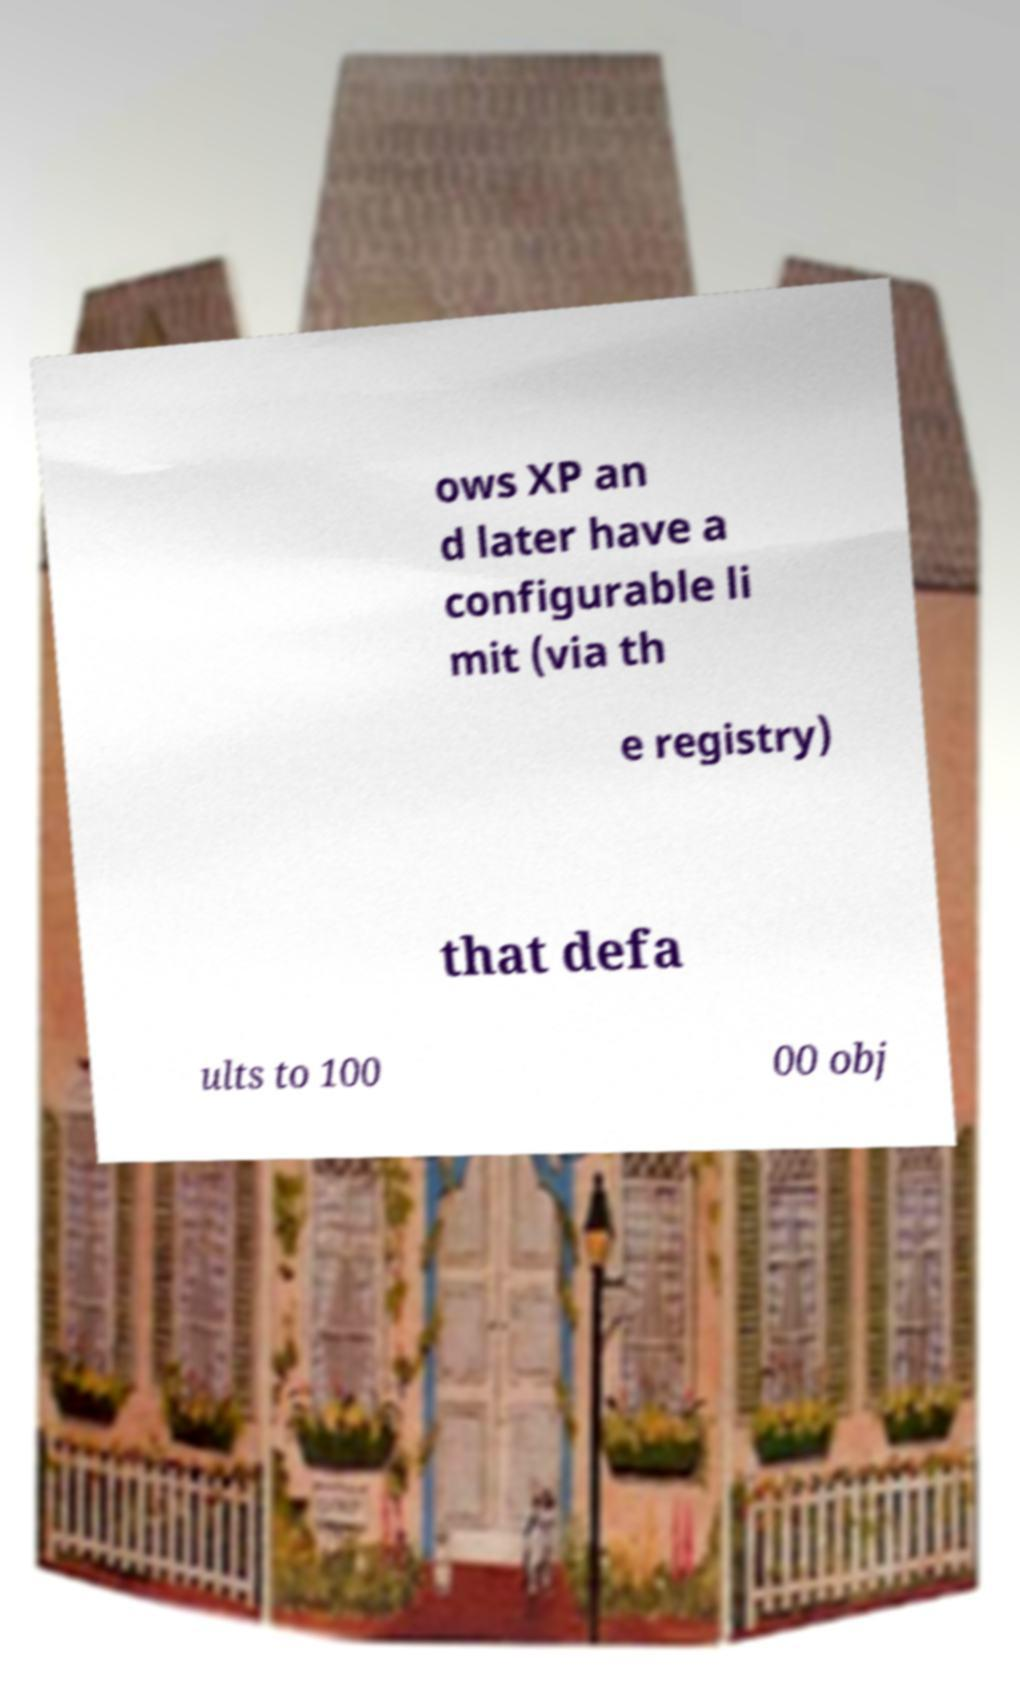I need the written content from this picture converted into text. Can you do that? ows XP an d later have a configurable li mit (via th e registry) that defa ults to 100 00 obj 